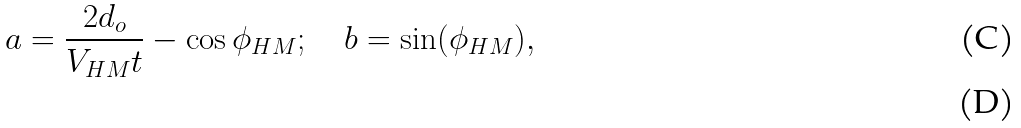<formula> <loc_0><loc_0><loc_500><loc_500>a = \frac { 2 d _ { o } } { V _ { H M } t } - \cos { \phi _ { H M } } ; \quad b = \sin ( \phi _ { H M } ) , \\</formula> 